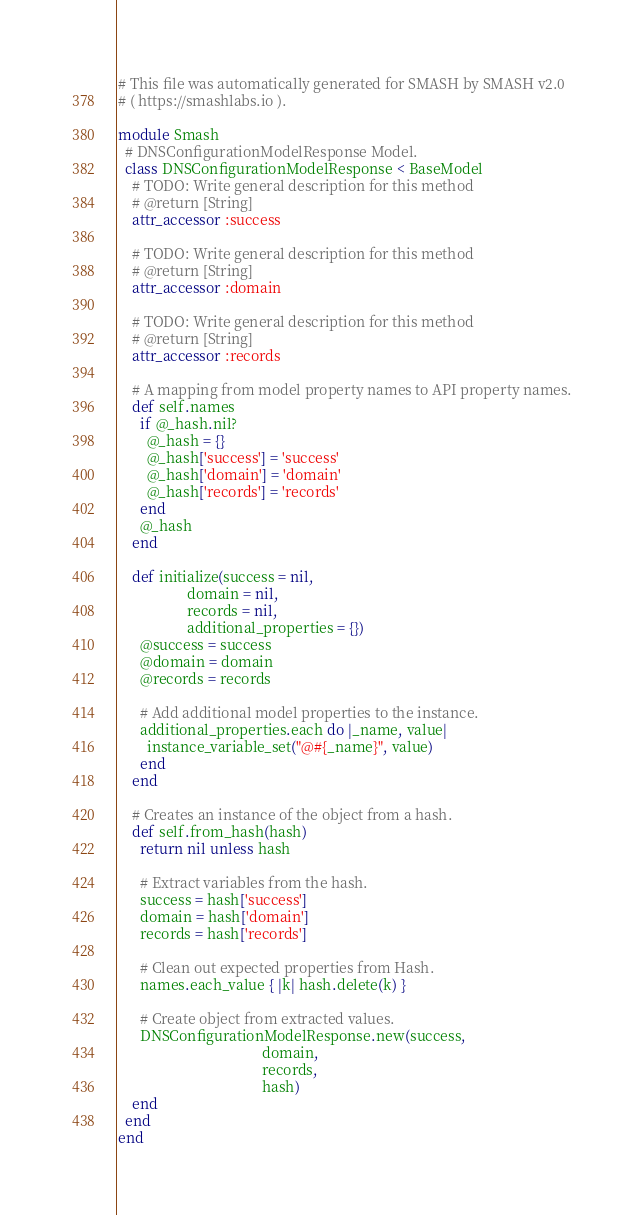<code> <loc_0><loc_0><loc_500><loc_500><_Ruby_># This file was automatically generated for SMASH by SMASH v2.0
# ( https://smashlabs.io ).

module Smash
  # DNSConfigurationModelResponse Model.
  class DNSConfigurationModelResponse < BaseModel
    # TODO: Write general description for this method
    # @return [String]
    attr_accessor :success

    # TODO: Write general description for this method
    # @return [String]
    attr_accessor :domain

    # TODO: Write general description for this method
    # @return [String]
    attr_accessor :records

    # A mapping from model property names to API property names.
    def self.names
      if @_hash.nil?
        @_hash = {}
        @_hash['success'] = 'success'
        @_hash['domain'] = 'domain'
        @_hash['records'] = 'records'
      end
      @_hash
    end

    def initialize(success = nil,
                   domain = nil,
                   records = nil,
                   additional_properties = {})
      @success = success
      @domain = domain
      @records = records

      # Add additional model properties to the instance.
      additional_properties.each do |_name, value|
        instance_variable_set("@#{_name}", value)
      end
    end

    # Creates an instance of the object from a hash.
    def self.from_hash(hash)
      return nil unless hash

      # Extract variables from the hash.
      success = hash['success']
      domain = hash['domain']
      records = hash['records']

      # Clean out expected properties from Hash.
      names.each_value { |k| hash.delete(k) }

      # Create object from extracted values.
      DNSConfigurationModelResponse.new(success,
                                        domain,
                                        records,
                                        hash)
    end
  end
end
</code> 